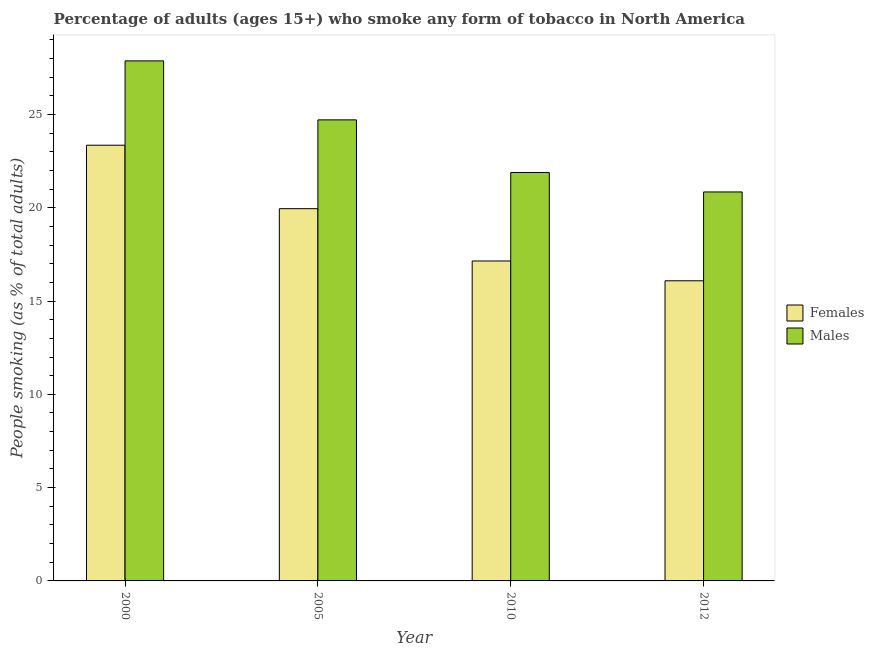How many groups of bars are there?
Your response must be concise. 4. Are the number of bars per tick equal to the number of legend labels?
Ensure brevity in your answer.  Yes. How many bars are there on the 3rd tick from the left?
Offer a very short reply. 2. How many bars are there on the 3rd tick from the right?
Make the answer very short. 2. What is the label of the 3rd group of bars from the left?
Your response must be concise. 2010. In how many cases, is the number of bars for a given year not equal to the number of legend labels?
Offer a terse response. 0. What is the percentage of males who smoke in 2005?
Your answer should be compact. 24.71. Across all years, what is the maximum percentage of males who smoke?
Offer a very short reply. 27.87. Across all years, what is the minimum percentage of males who smoke?
Ensure brevity in your answer.  20.85. In which year was the percentage of females who smoke maximum?
Provide a succinct answer. 2000. What is the total percentage of females who smoke in the graph?
Make the answer very short. 76.54. What is the difference between the percentage of females who smoke in 2005 and that in 2012?
Your answer should be very brief. 3.86. What is the difference between the percentage of males who smoke in 2005 and the percentage of females who smoke in 2010?
Your answer should be very brief. 2.82. What is the average percentage of males who smoke per year?
Offer a terse response. 23.83. In how many years, is the percentage of females who smoke greater than 2 %?
Make the answer very short. 4. What is the ratio of the percentage of males who smoke in 2000 to that in 2005?
Give a very brief answer. 1.13. Is the difference between the percentage of females who smoke in 2000 and 2005 greater than the difference between the percentage of males who smoke in 2000 and 2005?
Make the answer very short. No. What is the difference between the highest and the second highest percentage of males who smoke?
Provide a short and direct response. 3.16. What is the difference between the highest and the lowest percentage of females who smoke?
Your answer should be very brief. 7.27. Is the sum of the percentage of females who smoke in 2000 and 2005 greater than the maximum percentage of males who smoke across all years?
Provide a succinct answer. Yes. What does the 2nd bar from the left in 2010 represents?
Ensure brevity in your answer.  Males. What does the 2nd bar from the right in 2000 represents?
Give a very brief answer. Females. How many years are there in the graph?
Offer a terse response. 4. What is the difference between two consecutive major ticks on the Y-axis?
Ensure brevity in your answer.  5. Are the values on the major ticks of Y-axis written in scientific E-notation?
Your answer should be very brief. No. Does the graph contain grids?
Make the answer very short. No. How many legend labels are there?
Keep it short and to the point. 2. What is the title of the graph?
Your response must be concise. Percentage of adults (ages 15+) who smoke any form of tobacco in North America. Does "DAC donors" appear as one of the legend labels in the graph?
Offer a very short reply. No. What is the label or title of the X-axis?
Keep it short and to the point. Year. What is the label or title of the Y-axis?
Your response must be concise. People smoking (as % of total adults). What is the People smoking (as % of total adults) of Females in 2000?
Ensure brevity in your answer.  23.35. What is the People smoking (as % of total adults) of Males in 2000?
Provide a succinct answer. 27.87. What is the People smoking (as % of total adults) of Females in 2005?
Offer a very short reply. 19.95. What is the People smoking (as % of total adults) in Males in 2005?
Provide a short and direct response. 24.71. What is the People smoking (as % of total adults) in Females in 2010?
Offer a very short reply. 17.15. What is the People smoking (as % of total adults) of Males in 2010?
Keep it short and to the point. 21.89. What is the People smoking (as % of total adults) of Females in 2012?
Keep it short and to the point. 16.09. What is the People smoking (as % of total adults) in Males in 2012?
Provide a succinct answer. 20.85. Across all years, what is the maximum People smoking (as % of total adults) of Females?
Provide a short and direct response. 23.35. Across all years, what is the maximum People smoking (as % of total adults) in Males?
Your answer should be very brief. 27.87. Across all years, what is the minimum People smoking (as % of total adults) in Females?
Your response must be concise. 16.09. Across all years, what is the minimum People smoking (as % of total adults) of Males?
Your response must be concise. 20.85. What is the total People smoking (as % of total adults) of Females in the graph?
Your answer should be compact. 76.54. What is the total People smoking (as % of total adults) in Males in the graph?
Keep it short and to the point. 95.32. What is the difference between the People smoking (as % of total adults) of Females in 2000 and that in 2005?
Your response must be concise. 3.4. What is the difference between the People smoking (as % of total adults) of Males in 2000 and that in 2005?
Ensure brevity in your answer.  3.16. What is the difference between the People smoking (as % of total adults) in Females in 2000 and that in 2010?
Offer a very short reply. 6.2. What is the difference between the People smoking (as % of total adults) of Males in 2000 and that in 2010?
Offer a very short reply. 5.98. What is the difference between the People smoking (as % of total adults) in Females in 2000 and that in 2012?
Provide a short and direct response. 7.27. What is the difference between the People smoking (as % of total adults) of Males in 2000 and that in 2012?
Your answer should be very brief. 7.02. What is the difference between the People smoking (as % of total adults) in Females in 2005 and that in 2010?
Your answer should be very brief. 2.8. What is the difference between the People smoking (as % of total adults) in Males in 2005 and that in 2010?
Keep it short and to the point. 2.82. What is the difference between the People smoking (as % of total adults) of Females in 2005 and that in 2012?
Offer a very short reply. 3.86. What is the difference between the People smoking (as % of total adults) of Males in 2005 and that in 2012?
Offer a terse response. 3.86. What is the difference between the People smoking (as % of total adults) of Females in 2010 and that in 2012?
Your answer should be compact. 1.06. What is the difference between the People smoking (as % of total adults) of Males in 2010 and that in 2012?
Ensure brevity in your answer.  1.04. What is the difference between the People smoking (as % of total adults) of Females in 2000 and the People smoking (as % of total adults) of Males in 2005?
Make the answer very short. -1.36. What is the difference between the People smoking (as % of total adults) in Females in 2000 and the People smoking (as % of total adults) in Males in 2010?
Provide a succinct answer. 1.46. What is the difference between the People smoking (as % of total adults) in Females in 2000 and the People smoking (as % of total adults) in Males in 2012?
Offer a very short reply. 2.51. What is the difference between the People smoking (as % of total adults) of Females in 2005 and the People smoking (as % of total adults) of Males in 2010?
Give a very brief answer. -1.94. What is the difference between the People smoking (as % of total adults) of Females in 2005 and the People smoking (as % of total adults) of Males in 2012?
Offer a terse response. -0.9. What is the difference between the People smoking (as % of total adults) in Females in 2010 and the People smoking (as % of total adults) in Males in 2012?
Offer a very short reply. -3.7. What is the average People smoking (as % of total adults) of Females per year?
Your answer should be very brief. 19.13. What is the average People smoking (as % of total adults) of Males per year?
Offer a terse response. 23.83. In the year 2000, what is the difference between the People smoking (as % of total adults) of Females and People smoking (as % of total adults) of Males?
Make the answer very short. -4.52. In the year 2005, what is the difference between the People smoking (as % of total adults) in Females and People smoking (as % of total adults) in Males?
Provide a succinct answer. -4.76. In the year 2010, what is the difference between the People smoking (as % of total adults) in Females and People smoking (as % of total adults) in Males?
Keep it short and to the point. -4.74. In the year 2012, what is the difference between the People smoking (as % of total adults) of Females and People smoking (as % of total adults) of Males?
Ensure brevity in your answer.  -4.76. What is the ratio of the People smoking (as % of total adults) of Females in 2000 to that in 2005?
Make the answer very short. 1.17. What is the ratio of the People smoking (as % of total adults) of Males in 2000 to that in 2005?
Provide a succinct answer. 1.13. What is the ratio of the People smoking (as % of total adults) of Females in 2000 to that in 2010?
Provide a succinct answer. 1.36. What is the ratio of the People smoking (as % of total adults) in Males in 2000 to that in 2010?
Offer a very short reply. 1.27. What is the ratio of the People smoking (as % of total adults) in Females in 2000 to that in 2012?
Your response must be concise. 1.45. What is the ratio of the People smoking (as % of total adults) in Males in 2000 to that in 2012?
Make the answer very short. 1.34. What is the ratio of the People smoking (as % of total adults) of Females in 2005 to that in 2010?
Provide a short and direct response. 1.16. What is the ratio of the People smoking (as % of total adults) of Males in 2005 to that in 2010?
Offer a terse response. 1.13. What is the ratio of the People smoking (as % of total adults) in Females in 2005 to that in 2012?
Ensure brevity in your answer.  1.24. What is the ratio of the People smoking (as % of total adults) in Males in 2005 to that in 2012?
Provide a succinct answer. 1.19. What is the ratio of the People smoking (as % of total adults) in Females in 2010 to that in 2012?
Offer a terse response. 1.07. What is the ratio of the People smoking (as % of total adults) of Males in 2010 to that in 2012?
Give a very brief answer. 1.05. What is the difference between the highest and the second highest People smoking (as % of total adults) of Females?
Offer a very short reply. 3.4. What is the difference between the highest and the second highest People smoking (as % of total adults) of Males?
Your response must be concise. 3.16. What is the difference between the highest and the lowest People smoking (as % of total adults) of Females?
Your answer should be very brief. 7.27. What is the difference between the highest and the lowest People smoking (as % of total adults) of Males?
Keep it short and to the point. 7.02. 